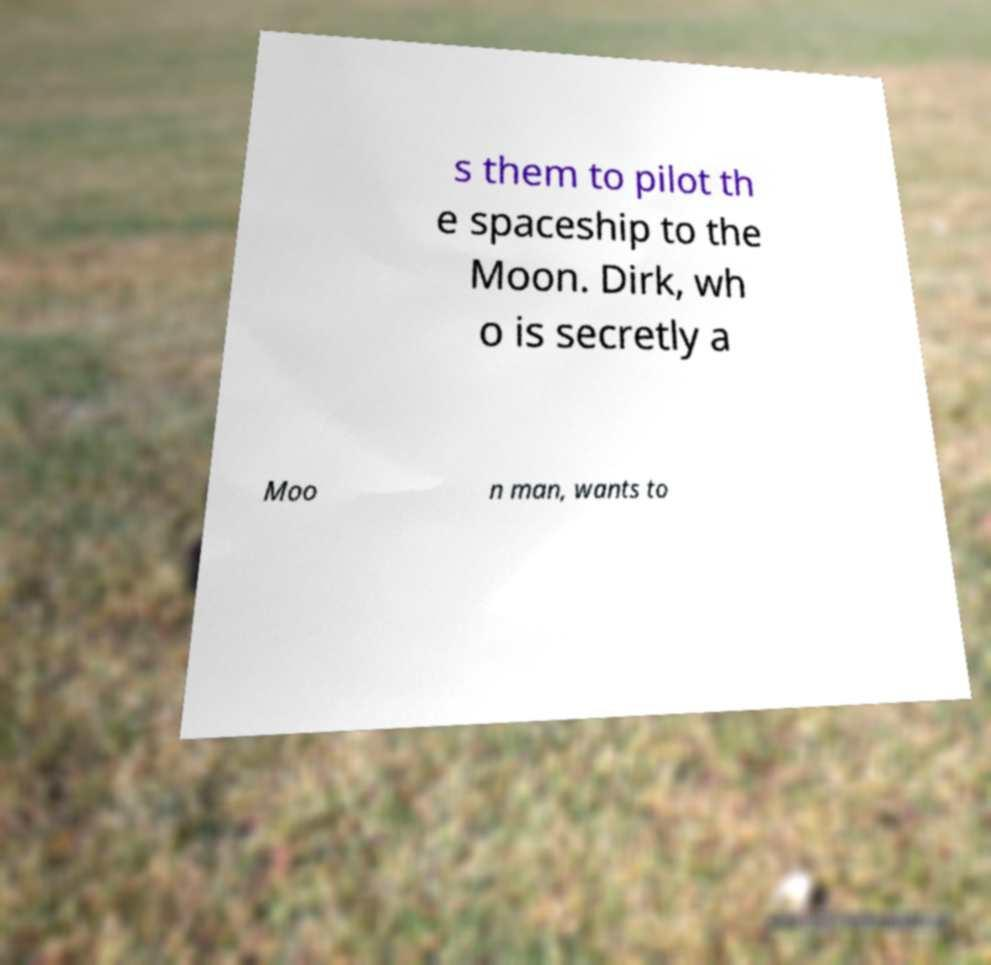Can you accurately transcribe the text from the provided image for me? s them to pilot th e spaceship to the Moon. Dirk, wh o is secretly a Moo n man, wants to 